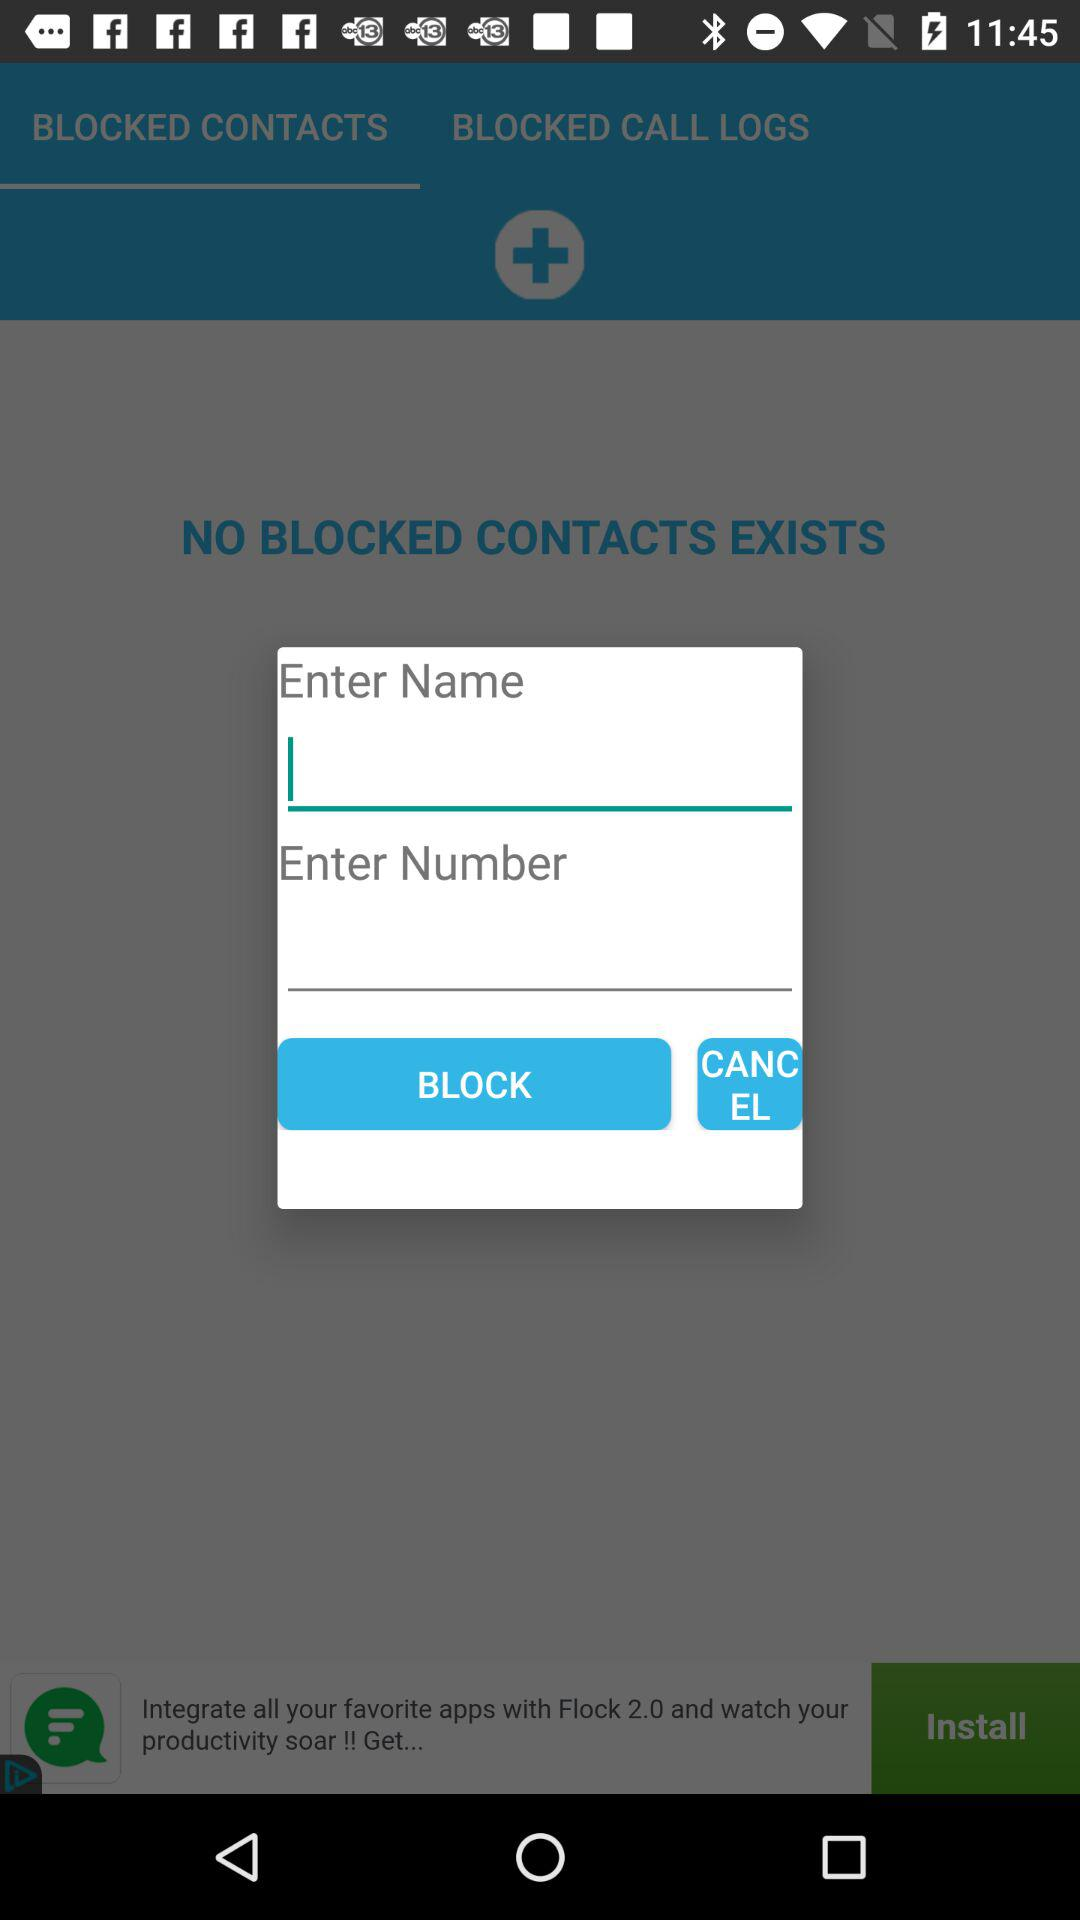Which tab is selected? The selected tab is "BLOCKED CONTACTS". 